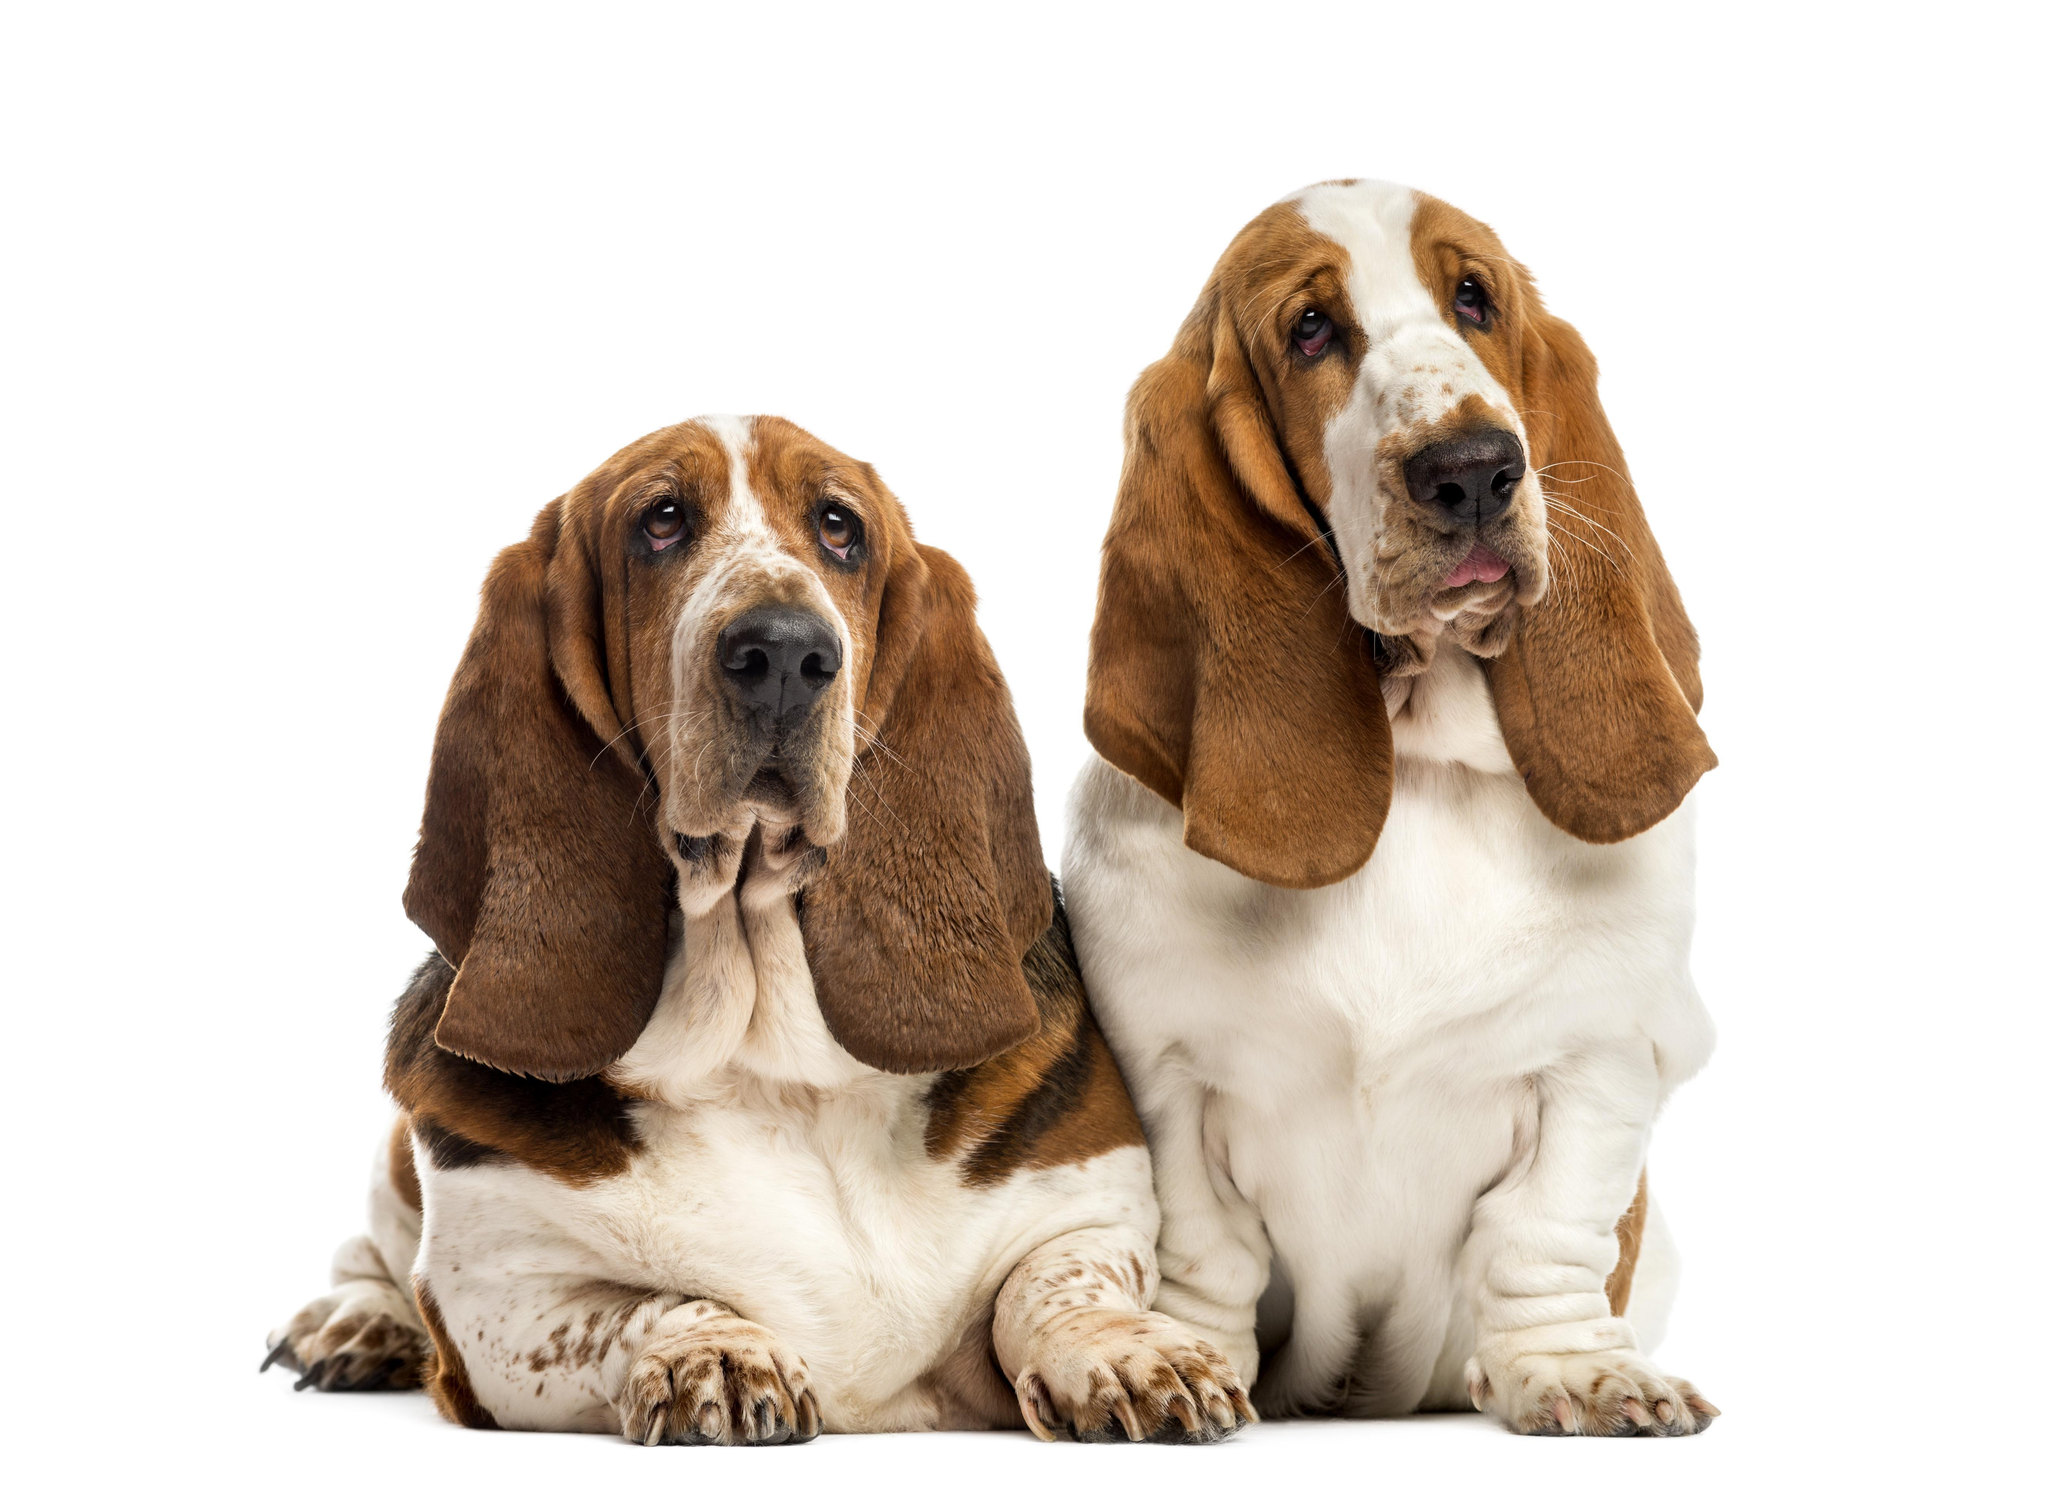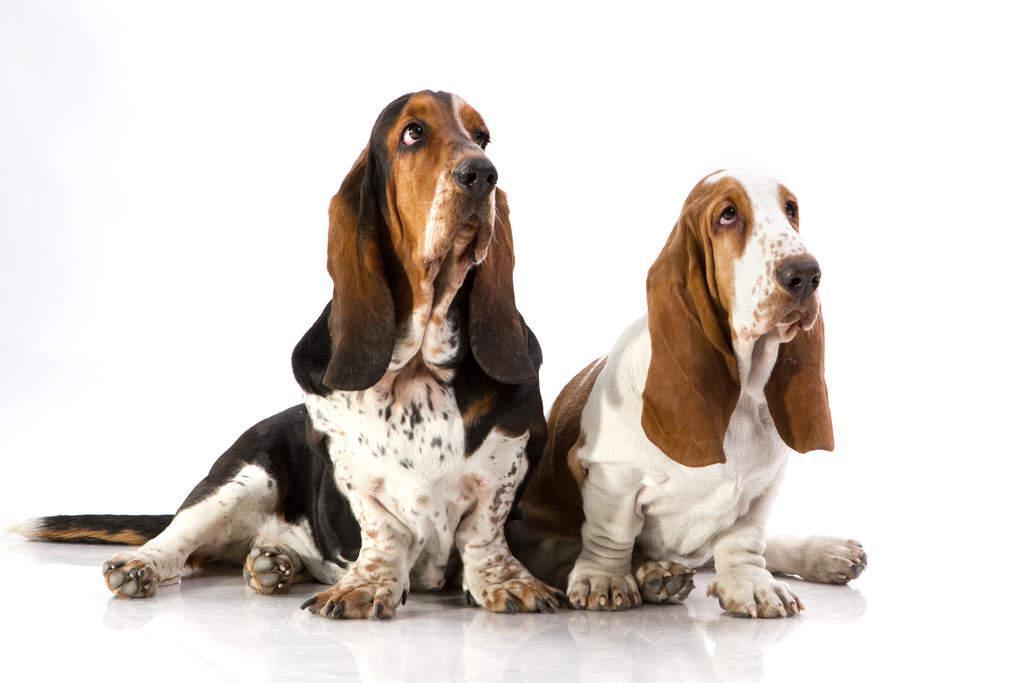The first image is the image on the left, the second image is the image on the right. Evaluate the accuracy of this statement regarding the images: "An image shows a long-eared basset hound posed next to another type of pet.". Is it true? Answer yes or no. No. The first image is the image on the left, the second image is the image on the right. Analyze the images presented: Is the assertion "Two dogs with brown and white coloring are in each image, sitting side by side, with the head of one higher, and front paws forward and flat." valid? Answer yes or no. Yes. 